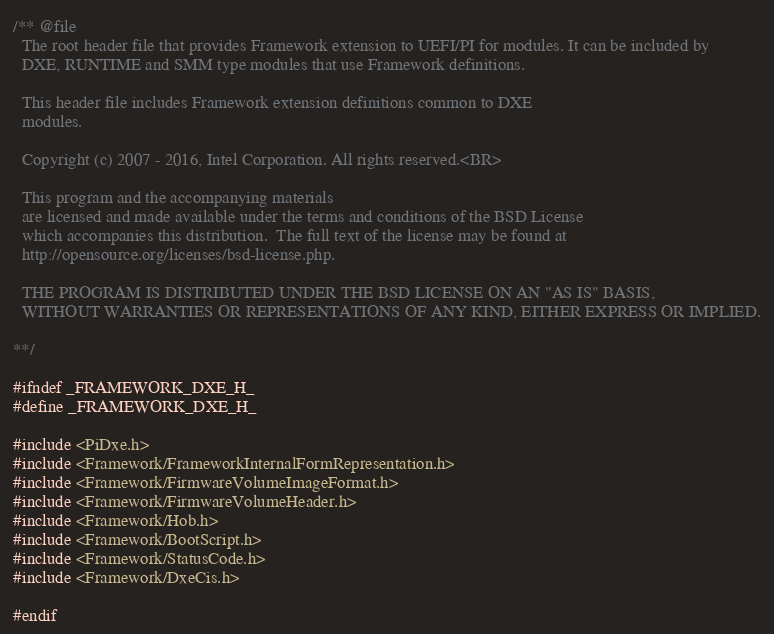Convert code to text. <code><loc_0><loc_0><loc_500><loc_500><_C_>/** @file
  The root header file that provides Framework extension to UEFI/PI for modules. It can be included by
  DXE, RUNTIME and SMM type modules that use Framework definitions.

  This header file includes Framework extension definitions common to DXE
  modules.

  Copyright (c) 2007 - 2016, Intel Corporation. All rights reserved.<BR>

  This program and the accompanying materials
  are licensed and made available under the terms and conditions of the BSD License
  which accompanies this distribution.  The full text of the license may be found at
  http://opensource.org/licenses/bsd-license.php.

  THE PROGRAM IS DISTRIBUTED UNDER THE BSD LICENSE ON AN "AS IS" BASIS,
  WITHOUT WARRANTIES OR REPRESENTATIONS OF ANY KIND, EITHER EXPRESS OR IMPLIED.

**/

#ifndef _FRAMEWORK_DXE_H_
#define _FRAMEWORK_DXE_H_

#include <PiDxe.h>
#include <Framework/FrameworkInternalFormRepresentation.h>
#include <Framework/FirmwareVolumeImageFormat.h>
#include <Framework/FirmwareVolumeHeader.h>
#include <Framework/Hob.h>
#include <Framework/BootScript.h>
#include <Framework/StatusCode.h>
#include <Framework/DxeCis.h>

#endif

</code> 